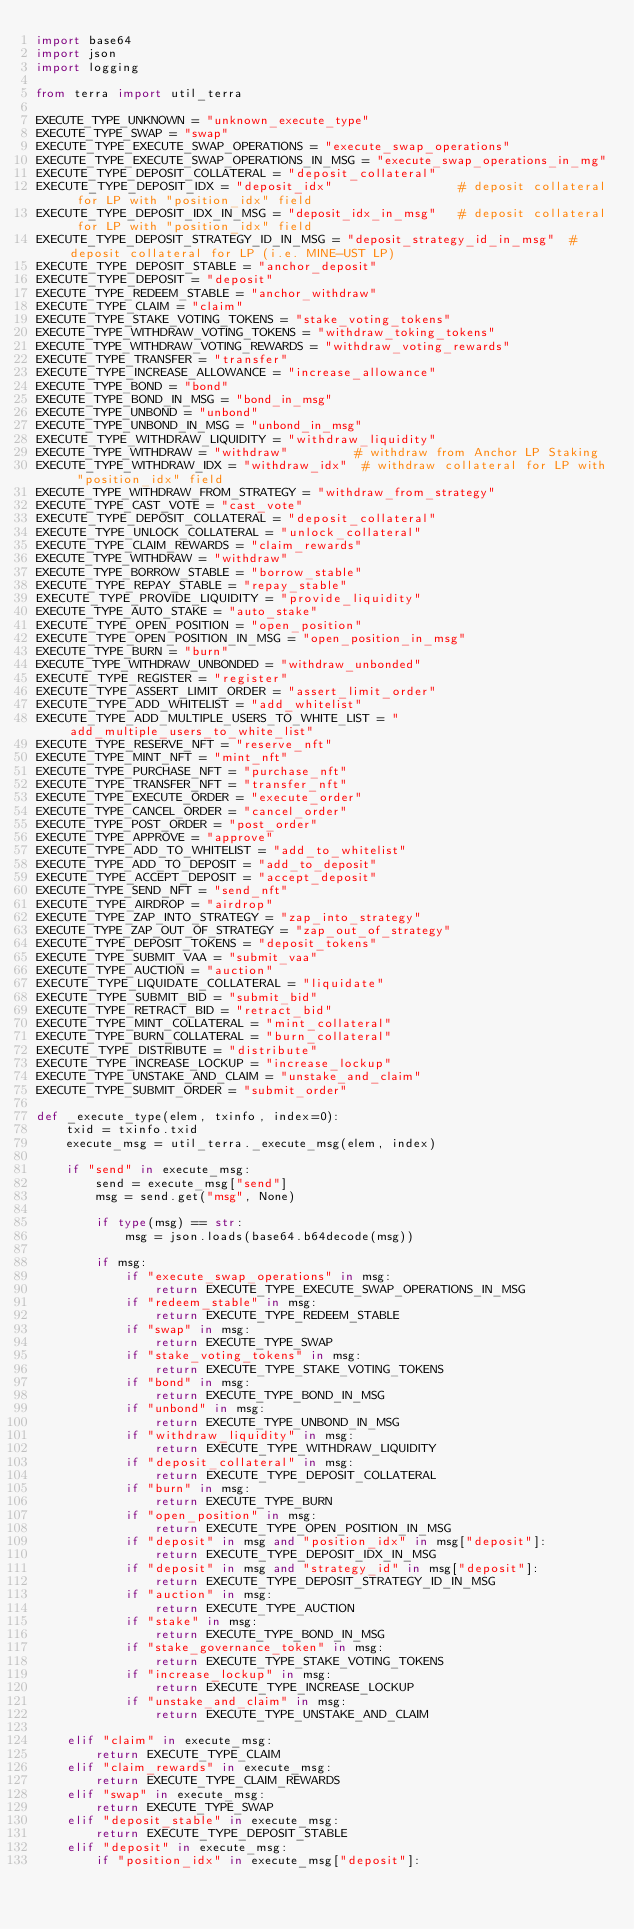Convert code to text. <code><loc_0><loc_0><loc_500><loc_500><_Python_>import base64
import json
import logging

from terra import util_terra

EXECUTE_TYPE_UNKNOWN = "unknown_execute_type"
EXECUTE_TYPE_SWAP = "swap"
EXECUTE_TYPE_EXECUTE_SWAP_OPERATIONS = "execute_swap_operations"
EXECUTE_TYPE_EXECUTE_SWAP_OPERATIONS_IN_MSG = "execute_swap_operations_in_mg"
EXECUTE_TYPE_DEPOSIT_COLLATERAL = "deposit_collateral"
EXECUTE_TYPE_DEPOSIT_IDX = "deposit_idx"                 # deposit collateral for LP with "position_idx" field
EXECUTE_TYPE_DEPOSIT_IDX_IN_MSG = "deposit_idx_in_msg"   # deposit collateral for LP with "position_idx" field
EXECUTE_TYPE_DEPOSIT_STRATEGY_ID_IN_MSG = "deposit_strategy_id_in_msg"  # deposit collateral for LP (i.e. MINE-UST LP)
EXECUTE_TYPE_DEPOSIT_STABLE = "anchor_deposit"
EXECUTE_TYPE_DEPOSIT = "deposit"
EXECUTE_TYPE_REDEEM_STABLE = "anchor_withdraw"
EXECUTE_TYPE_CLAIM = "claim"
EXECUTE_TYPE_STAKE_VOTING_TOKENS = "stake_voting_tokens"
EXECUTE_TYPE_WITHDRAW_VOTING_TOKENS = "withdraw_toking_tokens"
EXECUTE_TYPE_WITHDRAW_VOTING_REWARDS = "withdraw_voting_rewards"
EXECUTE_TYPE_TRANSFER = "transfer"
EXECUTE_TYPE_INCREASE_ALLOWANCE = "increase_allowance"
EXECUTE_TYPE_BOND = "bond"
EXECUTE_TYPE_BOND_IN_MSG = "bond_in_msg"
EXECUTE_TYPE_UNBOND = "unbond"
EXECUTE_TYPE_UNBOND_IN_MSG = "unbond_in_msg"
EXECUTE_TYPE_WITHDRAW_LIQUIDITY = "withdraw_liquidity"
EXECUTE_TYPE_WITHDRAW = "withdraw"         # withdraw from Anchor LP Staking
EXECUTE_TYPE_WITHDRAW_IDX = "withdraw_idx"  # withdraw collateral for LP with "position_idx" field
EXECUTE_TYPE_WITHDRAW_FROM_STRATEGY = "withdraw_from_strategy"
EXECUTE_TYPE_CAST_VOTE = "cast_vote"
EXECUTE_TYPE_DEPOSIT_COLLATERAL = "deposit_collateral"
EXECUTE_TYPE_UNLOCK_COLLATERAL = "unlock_collateral"
EXECUTE_TYPE_CLAIM_REWARDS = "claim_rewards"
EXECUTE_TYPE_WITHDRAW = "withdraw"
EXECUTE_TYPE_BORROW_STABLE = "borrow_stable"
EXECUTE_TYPE_REPAY_STABLE = "repay_stable"
EXECUTE_TYPE_PROVIDE_LIQUIDITY = "provide_liquidity"
EXECUTE_TYPE_AUTO_STAKE = "auto_stake"
EXECUTE_TYPE_OPEN_POSITION = "open_position"
EXECUTE_TYPE_OPEN_POSITION_IN_MSG = "open_position_in_msg"
EXECUTE_TYPE_BURN = "burn"
EXECUTE_TYPE_WITHDRAW_UNBONDED = "withdraw_unbonded"
EXECUTE_TYPE_REGISTER = "register"
EXECUTE_TYPE_ASSERT_LIMIT_ORDER = "assert_limit_order"
EXECUTE_TYPE_ADD_WHITELIST = "add_whitelist"
EXECUTE_TYPE_ADD_MULTIPLE_USERS_TO_WHITE_LIST = "add_multiple_users_to_white_list"
EXECUTE_TYPE_RESERVE_NFT = "reserve_nft"
EXECUTE_TYPE_MINT_NFT = "mint_nft"
EXECUTE_TYPE_PURCHASE_NFT = "purchase_nft"
EXECUTE_TYPE_TRANSFER_NFT = "transfer_nft"
EXECUTE_TYPE_EXECUTE_ORDER = "execute_order"
EXECUTE_TYPE_CANCEL_ORDER = "cancel_order"
EXECUTE_TYPE_POST_ORDER = "post_order"
EXECUTE_TYPE_APPROVE = "approve"
EXECUTE_TYPE_ADD_TO_WHITELIST = "add_to_whitelist"
EXECUTE_TYPE_ADD_TO_DEPOSIT = "add_to_deposit"
EXECUTE_TYPE_ACCEPT_DEPOSIT = "accept_deposit"
EXECUTE_TYPE_SEND_NFT = "send_nft"
EXECUTE_TYPE_AIRDROP = "airdrop"
EXECUTE_TYPE_ZAP_INTO_STRATEGY = "zap_into_strategy"
EXECUTE_TYPE_ZAP_OUT_OF_STRATEGY = "zap_out_of_strategy"
EXECUTE_TYPE_DEPOSIT_TOKENS = "deposit_tokens"
EXECUTE_TYPE_SUBMIT_VAA = "submit_vaa"
EXECUTE_TYPE_AUCTION = "auction"
EXECUTE_TYPE_LIQUIDATE_COLLATERAL = "liquidate"
EXECUTE_TYPE_SUBMIT_BID = "submit_bid"
EXECUTE_TYPE_RETRACT_BID = "retract_bid"
EXECUTE_TYPE_MINT_COLLATERAL = "mint_collateral"
EXECUTE_TYPE_BURN_COLLATERAL = "burn_collateral"
EXECUTE_TYPE_DISTRIBUTE = "distribute"
EXECUTE_TYPE_INCREASE_LOCKUP = "increase_lockup"
EXECUTE_TYPE_UNSTAKE_AND_CLAIM = "unstake_and_claim"
EXECUTE_TYPE_SUBMIT_ORDER = "submit_order"

def _execute_type(elem, txinfo, index=0):
    txid = txinfo.txid
    execute_msg = util_terra._execute_msg(elem, index)

    if "send" in execute_msg:
        send = execute_msg["send"]
        msg = send.get("msg", None)

        if type(msg) == str:
            msg = json.loads(base64.b64decode(msg))

        if msg:
            if "execute_swap_operations" in msg:
                return EXECUTE_TYPE_EXECUTE_SWAP_OPERATIONS_IN_MSG
            if "redeem_stable" in msg:
                return EXECUTE_TYPE_REDEEM_STABLE
            if "swap" in msg:
                return EXECUTE_TYPE_SWAP
            if "stake_voting_tokens" in msg:
                return EXECUTE_TYPE_STAKE_VOTING_TOKENS
            if "bond" in msg:
                return EXECUTE_TYPE_BOND_IN_MSG
            if "unbond" in msg:
                return EXECUTE_TYPE_UNBOND_IN_MSG
            if "withdraw_liquidity" in msg:
                return EXECUTE_TYPE_WITHDRAW_LIQUIDITY
            if "deposit_collateral" in msg:
                return EXECUTE_TYPE_DEPOSIT_COLLATERAL
            if "burn" in msg:
                return EXECUTE_TYPE_BURN
            if "open_position" in msg:
                return EXECUTE_TYPE_OPEN_POSITION_IN_MSG
            if "deposit" in msg and "position_idx" in msg["deposit"]:
                return EXECUTE_TYPE_DEPOSIT_IDX_IN_MSG
            if "deposit" in msg and "strategy_id" in msg["deposit"]:
                return EXECUTE_TYPE_DEPOSIT_STRATEGY_ID_IN_MSG
            if "auction" in msg:
                return EXECUTE_TYPE_AUCTION
            if "stake" in msg:
                return EXECUTE_TYPE_BOND_IN_MSG
            if "stake_governance_token" in msg:
                return EXECUTE_TYPE_STAKE_VOTING_TOKENS
            if "increase_lockup" in msg:
                return EXECUTE_TYPE_INCREASE_LOCKUP
            if "unstake_and_claim" in msg:
                return EXECUTE_TYPE_UNSTAKE_AND_CLAIM

    elif "claim" in execute_msg:
        return EXECUTE_TYPE_CLAIM
    elif "claim_rewards" in execute_msg:
        return EXECUTE_TYPE_CLAIM_REWARDS
    elif "swap" in execute_msg:
        return EXECUTE_TYPE_SWAP
    elif "deposit_stable" in execute_msg:
        return EXECUTE_TYPE_DEPOSIT_STABLE
    elif "deposit" in execute_msg:
        if "position_idx" in execute_msg["deposit"]:</code> 